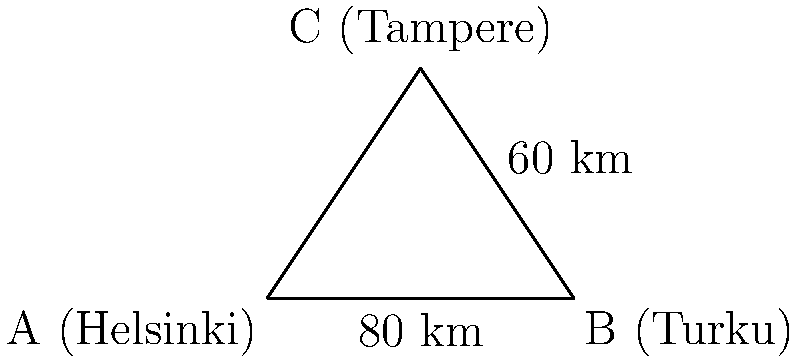24Rent has car rental locations in three Finnish cities: Helsinki (A), Turku (B), and Tampere (C). The distance between Helsinki and Turku is 80 km, and the distance between Turku and Tampere is 60 km. If the angle between these two routes at Turku is 90°, calculate the direct distance between Helsinki and Tampere using trigonometric functions. To solve this problem, we can use the Pythagorean theorem, which is a special case of trigonometry for right triangles.

Step 1: Identify the right triangle.
The triangle formed by Helsinki (A), Turku (B), and Tampere (C) is a right triangle with the right angle at B.

Step 2: Apply the Pythagorean theorem.
The Pythagorean theorem states that in a right triangle, the square of the length of the hypotenuse (c) is equal to the sum of squares of the other two sides (a and b).

$$c^2 = a^2 + b^2$$

Where:
a = distance between Helsinki and Turku = 80 km
b = distance between Turku and Tampere = 60 km
c = distance between Helsinki and Tampere (what we're solving for)

Step 3: Substitute the known values into the equation.
$$c^2 = 80^2 + 60^2$$

Step 4: Calculate the squares.
$$c^2 = 6400 + 3600 = 10000$$

Step 5: Take the square root of both sides.
$$c = \sqrt{10000} = 100$$

Therefore, the direct distance between Helsinki and Tampere is 100 km.
Answer: 100 km 